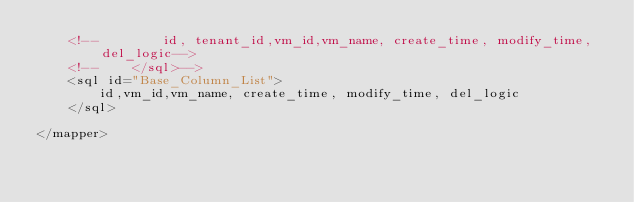Convert code to text. <code><loc_0><loc_0><loc_500><loc_500><_XML_>    <!--        id, tenant_id,vm_id,vm_name, create_time, modify_time, del_logic-->
    <!--    </sql>-->
    <sql id="Base_Column_List">
        id,vm_id,vm_name, create_time, modify_time, del_logic
    </sql>

</mapper></code> 